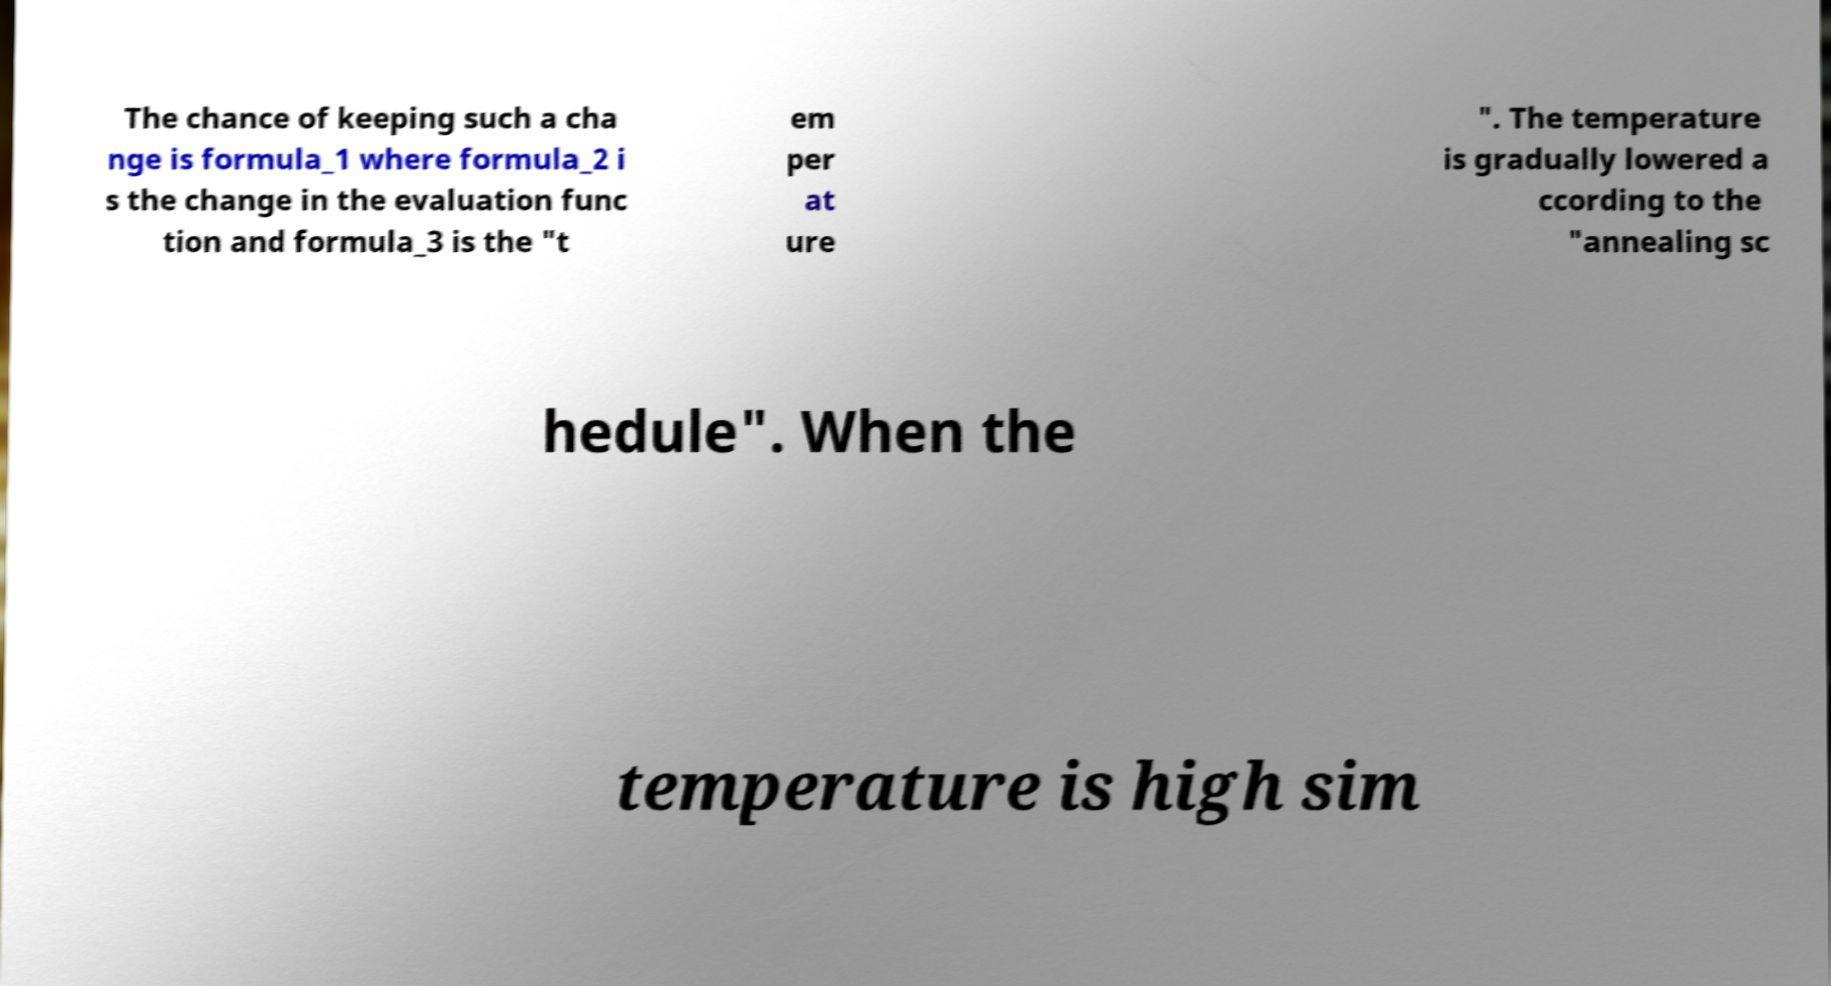What messages or text are displayed in this image? I need them in a readable, typed format. The chance of keeping such a cha nge is formula_1 where formula_2 i s the change in the evaluation func tion and formula_3 is the "t em per at ure ". The temperature is gradually lowered a ccording to the "annealing sc hedule". When the temperature is high sim 